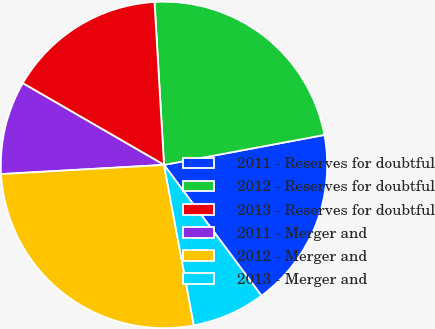<chart> <loc_0><loc_0><loc_500><loc_500><pie_chart><fcel>2011 - Reserves for doubtful<fcel>2012 - Reserves for doubtful<fcel>2013 - Reserves for doubtful<fcel>2011 - Merger and<fcel>2012 - Merger and<fcel>2013 - Merger and<nl><fcel>17.75%<fcel>22.99%<fcel>15.73%<fcel>9.24%<fcel>27.03%<fcel>7.26%<nl></chart> 